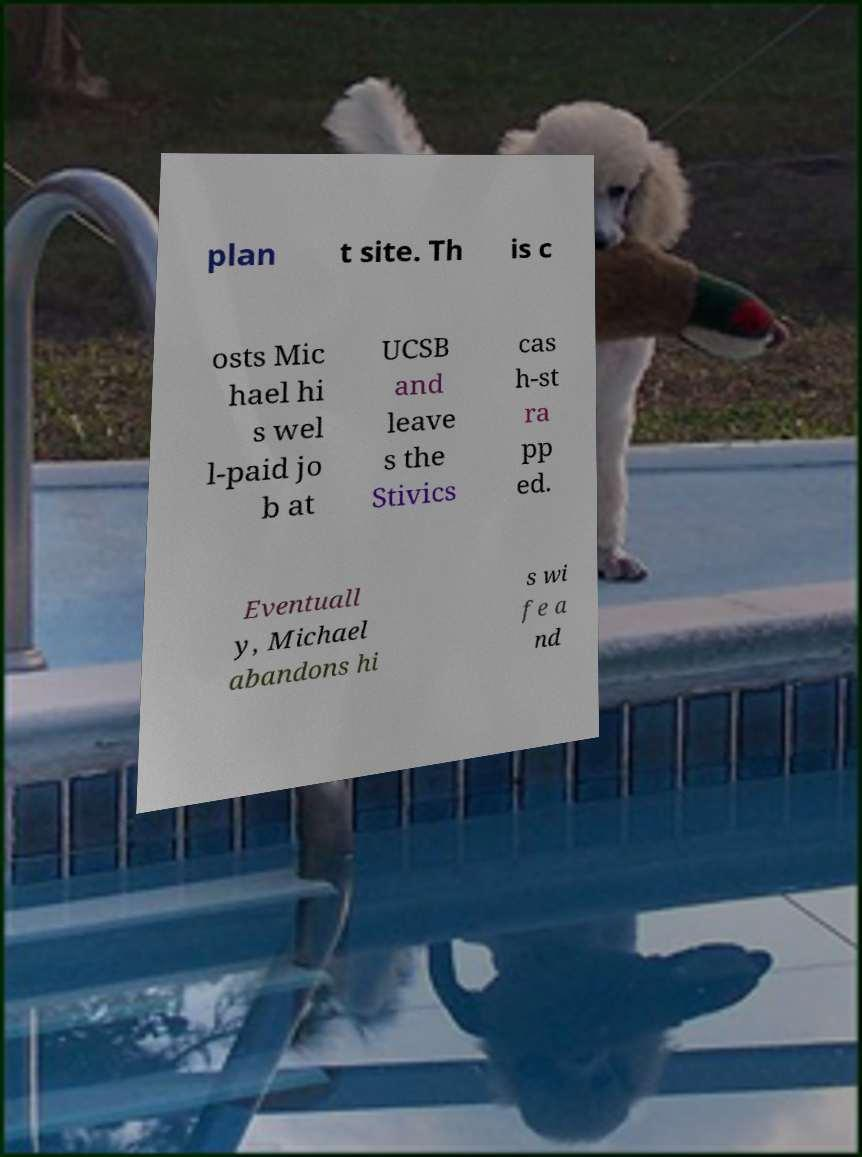I need the written content from this picture converted into text. Can you do that? plan t site. Th is c osts Mic hael hi s wel l-paid jo b at UCSB and leave s the Stivics cas h-st ra pp ed. Eventuall y, Michael abandons hi s wi fe a nd 